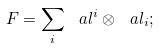Convert formula to latex. <formula><loc_0><loc_0><loc_500><loc_500>F = \sum _ { i } \ a l ^ { i } \otimes \ a l _ { i } ;</formula> 